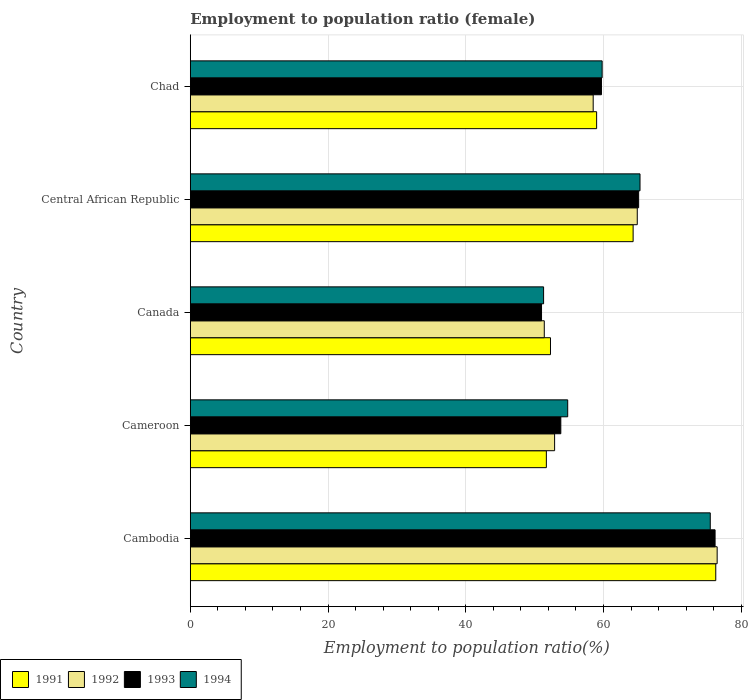Are the number of bars per tick equal to the number of legend labels?
Provide a short and direct response. Yes. How many bars are there on the 5th tick from the top?
Ensure brevity in your answer.  4. What is the label of the 5th group of bars from the top?
Keep it short and to the point. Cambodia. In how many cases, is the number of bars for a given country not equal to the number of legend labels?
Your response must be concise. 0. Across all countries, what is the maximum employment to population ratio in 1992?
Offer a terse response. 76.5. In which country was the employment to population ratio in 1993 maximum?
Your answer should be compact. Cambodia. What is the total employment to population ratio in 1991 in the graph?
Provide a short and direct response. 303.6. What is the difference between the employment to population ratio in 1993 in Canada and that in Chad?
Give a very brief answer. -8.7. What is the difference between the employment to population ratio in 1991 in Chad and the employment to population ratio in 1993 in Canada?
Offer a terse response. 8. What is the average employment to population ratio in 1993 per country?
Make the answer very short. 61.16. What is the difference between the employment to population ratio in 1992 and employment to population ratio in 1993 in Cambodia?
Ensure brevity in your answer.  0.3. In how many countries, is the employment to population ratio in 1991 greater than 32 %?
Your response must be concise. 5. What is the ratio of the employment to population ratio in 1994 in Central African Republic to that in Chad?
Offer a very short reply. 1.09. What is the difference between the highest and the second highest employment to population ratio in 1993?
Keep it short and to the point. 11.1. What is the difference between the highest and the lowest employment to population ratio in 1991?
Your response must be concise. 24.6. Is the sum of the employment to population ratio in 1994 in Cambodia and Central African Republic greater than the maximum employment to population ratio in 1992 across all countries?
Ensure brevity in your answer.  Yes. Is it the case that in every country, the sum of the employment to population ratio in 1992 and employment to population ratio in 1993 is greater than the sum of employment to population ratio in 1991 and employment to population ratio in 1994?
Keep it short and to the point. No. What does the 3rd bar from the top in Chad represents?
Give a very brief answer. 1992. What does the 1st bar from the bottom in Central African Republic represents?
Offer a very short reply. 1991. Are all the bars in the graph horizontal?
Your response must be concise. Yes. How many countries are there in the graph?
Your answer should be compact. 5. What is the difference between two consecutive major ticks on the X-axis?
Your answer should be very brief. 20. Does the graph contain any zero values?
Your answer should be compact. No. How are the legend labels stacked?
Offer a very short reply. Horizontal. What is the title of the graph?
Make the answer very short. Employment to population ratio (female). What is the label or title of the Y-axis?
Keep it short and to the point. Country. What is the Employment to population ratio(%) of 1991 in Cambodia?
Your answer should be very brief. 76.3. What is the Employment to population ratio(%) of 1992 in Cambodia?
Make the answer very short. 76.5. What is the Employment to population ratio(%) in 1993 in Cambodia?
Give a very brief answer. 76.2. What is the Employment to population ratio(%) of 1994 in Cambodia?
Provide a succinct answer. 75.5. What is the Employment to population ratio(%) in 1991 in Cameroon?
Your answer should be very brief. 51.7. What is the Employment to population ratio(%) of 1992 in Cameroon?
Keep it short and to the point. 52.9. What is the Employment to population ratio(%) of 1993 in Cameroon?
Provide a succinct answer. 53.8. What is the Employment to population ratio(%) of 1994 in Cameroon?
Your answer should be compact. 54.8. What is the Employment to population ratio(%) in 1991 in Canada?
Provide a succinct answer. 52.3. What is the Employment to population ratio(%) in 1992 in Canada?
Give a very brief answer. 51.4. What is the Employment to population ratio(%) of 1994 in Canada?
Your answer should be very brief. 51.3. What is the Employment to population ratio(%) in 1991 in Central African Republic?
Keep it short and to the point. 64.3. What is the Employment to population ratio(%) in 1992 in Central African Republic?
Keep it short and to the point. 64.9. What is the Employment to population ratio(%) of 1993 in Central African Republic?
Your answer should be compact. 65.1. What is the Employment to population ratio(%) of 1994 in Central African Republic?
Make the answer very short. 65.3. What is the Employment to population ratio(%) of 1991 in Chad?
Offer a terse response. 59. What is the Employment to population ratio(%) in 1992 in Chad?
Ensure brevity in your answer.  58.5. What is the Employment to population ratio(%) in 1993 in Chad?
Your answer should be very brief. 59.7. What is the Employment to population ratio(%) of 1994 in Chad?
Provide a short and direct response. 59.8. Across all countries, what is the maximum Employment to population ratio(%) of 1991?
Your answer should be compact. 76.3. Across all countries, what is the maximum Employment to population ratio(%) in 1992?
Keep it short and to the point. 76.5. Across all countries, what is the maximum Employment to population ratio(%) of 1993?
Make the answer very short. 76.2. Across all countries, what is the maximum Employment to population ratio(%) of 1994?
Keep it short and to the point. 75.5. Across all countries, what is the minimum Employment to population ratio(%) in 1991?
Keep it short and to the point. 51.7. Across all countries, what is the minimum Employment to population ratio(%) in 1992?
Give a very brief answer. 51.4. Across all countries, what is the minimum Employment to population ratio(%) in 1994?
Provide a short and direct response. 51.3. What is the total Employment to population ratio(%) in 1991 in the graph?
Your answer should be compact. 303.6. What is the total Employment to population ratio(%) of 1992 in the graph?
Give a very brief answer. 304.2. What is the total Employment to population ratio(%) in 1993 in the graph?
Offer a very short reply. 305.8. What is the total Employment to population ratio(%) of 1994 in the graph?
Your response must be concise. 306.7. What is the difference between the Employment to population ratio(%) in 1991 in Cambodia and that in Cameroon?
Make the answer very short. 24.6. What is the difference between the Employment to population ratio(%) of 1992 in Cambodia and that in Cameroon?
Offer a very short reply. 23.6. What is the difference between the Employment to population ratio(%) of 1993 in Cambodia and that in Cameroon?
Your response must be concise. 22.4. What is the difference between the Employment to population ratio(%) of 1994 in Cambodia and that in Cameroon?
Your answer should be compact. 20.7. What is the difference between the Employment to population ratio(%) of 1992 in Cambodia and that in Canada?
Your response must be concise. 25.1. What is the difference between the Employment to population ratio(%) in 1993 in Cambodia and that in Canada?
Make the answer very short. 25.2. What is the difference between the Employment to population ratio(%) of 1994 in Cambodia and that in Canada?
Your answer should be very brief. 24.2. What is the difference between the Employment to population ratio(%) of 1994 in Cambodia and that in Central African Republic?
Ensure brevity in your answer.  10.2. What is the difference between the Employment to population ratio(%) of 1992 in Cambodia and that in Chad?
Your answer should be compact. 18. What is the difference between the Employment to population ratio(%) in 1991 in Cameroon and that in Canada?
Your answer should be compact. -0.6. What is the difference between the Employment to population ratio(%) of 1991 in Cameroon and that in Central African Republic?
Keep it short and to the point. -12.6. What is the difference between the Employment to population ratio(%) in 1992 in Cameroon and that in Central African Republic?
Keep it short and to the point. -12. What is the difference between the Employment to population ratio(%) of 1994 in Cameroon and that in Central African Republic?
Ensure brevity in your answer.  -10.5. What is the difference between the Employment to population ratio(%) of 1991 in Cameroon and that in Chad?
Your answer should be compact. -7.3. What is the difference between the Employment to population ratio(%) in 1994 in Cameroon and that in Chad?
Give a very brief answer. -5. What is the difference between the Employment to population ratio(%) in 1992 in Canada and that in Central African Republic?
Give a very brief answer. -13.5. What is the difference between the Employment to population ratio(%) in 1993 in Canada and that in Central African Republic?
Offer a terse response. -14.1. What is the difference between the Employment to population ratio(%) of 1993 in Canada and that in Chad?
Make the answer very short. -8.7. What is the difference between the Employment to population ratio(%) in 1991 in Central African Republic and that in Chad?
Give a very brief answer. 5.3. What is the difference between the Employment to population ratio(%) of 1994 in Central African Republic and that in Chad?
Your response must be concise. 5.5. What is the difference between the Employment to population ratio(%) of 1991 in Cambodia and the Employment to population ratio(%) of 1992 in Cameroon?
Offer a very short reply. 23.4. What is the difference between the Employment to population ratio(%) in 1991 in Cambodia and the Employment to population ratio(%) in 1993 in Cameroon?
Offer a terse response. 22.5. What is the difference between the Employment to population ratio(%) of 1991 in Cambodia and the Employment to population ratio(%) of 1994 in Cameroon?
Provide a succinct answer. 21.5. What is the difference between the Employment to population ratio(%) of 1992 in Cambodia and the Employment to population ratio(%) of 1993 in Cameroon?
Your response must be concise. 22.7. What is the difference between the Employment to population ratio(%) in 1992 in Cambodia and the Employment to population ratio(%) in 1994 in Cameroon?
Make the answer very short. 21.7. What is the difference between the Employment to population ratio(%) in 1993 in Cambodia and the Employment to population ratio(%) in 1994 in Cameroon?
Ensure brevity in your answer.  21.4. What is the difference between the Employment to population ratio(%) of 1991 in Cambodia and the Employment to population ratio(%) of 1992 in Canada?
Make the answer very short. 24.9. What is the difference between the Employment to population ratio(%) of 1991 in Cambodia and the Employment to population ratio(%) of 1993 in Canada?
Ensure brevity in your answer.  25.3. What is the difference between the Employment to population ratio(%) of 1992 in Cambodia and the Employment to population ratio(%) of 1994 in Canada?
Your response must be concise. 25.2. What is the difference between the Employment to population ratio(%) of 1993 in Cambodia and the Employment to population ratio(%) of 1994 in Canada?
Ensure brevity in your answer.  24.9. What is the difference between the Employment to population ratio(%) in 1991 in Cambodia and the Employment to population ratio(%) in 1993 in Central African Republic?
Keep it short and to the point. 11.2. What is the difference between the Employment to population ratio(%) in 1991 in Cambodia and the Employment to population ratio(%) in 1994 in Central African Republic?
Offer a terse response. 11. What is the difference between the Employment to population ratio(%) of 1992 in Cambodia and the Employment to population ratio(%) of 1993 in Central African Republic?
Provide a short and direct response. 11.4. What is the difference between the Employment to population ratio(%) of 1992 in Cambodia and the Employment to population ratio(%) of 1994 in Central African Republic?
Your answer should be very brief. 11.2. What is the difference between the Employment to population ratio(%) in 1991 in Cameroon and the Employment to population ratio(%) in 1992 in Canada?
Offer a terse response. 0.3. What is the difference between the Employment to population ratio(%) in 1992 in Cameroon and the Employment to population ratio(%) in 1993 in Canada?
Ensure brevity in your answer.  1.9. What is the difference between the Employment to population ratio(%) of 1991 in Cameroon and the Employment to population ratio(%) of 1992 in Central African Republic?
Give a very brief answer. -13.2. What is the difference between the Employment to population ratio(%) in 1991 in Cameroon and the Employment to population ratio(%) in 1993 in Central African Republic?
Provide a short and direct response. -13.4. What is the difference between the Employment to population ratio(%) of 1993 in Cameroon and the Employment to population ratio(%) of 1994 in Central African Republic?
Your answer should be compact. -11.5. What is the difference between the Employment to population ratio(%) of 1991 in Cameroon and the Employment to population ratio(%) of 1994 in Chad?
Provide a succinct answer. -8.1. What is the difference between the Employment to population ratio(%) of 1993 in Cameroon and the Employment to population ratio(%) of 1994 in Chad?
Offer a terse response. -6. What is the difference between the Employment to population ratio(%) in 1991 in Canada and the Employment to population ratio(%) in 1994 in Central African Republic?
Ensure brevity in your answer.  -13. What is the difference between the Employment to population ratio(%) of 1992 in Canada and the Employment to population ratio(%) of 1993 in Central African Republic?
Your answer should be compact. -13.7. What is the difference between the Employment to population ratio(%) in 1993 in Canada and the Employment to population ratio(%) in 1994 in Central African Republic?
Keep it short and to the point. -14.3. What is the difference between the Employment to population ratio(%) in 1991 in Canada and the Employment to population ratio(%) in 1993 in Chad?
Provide a succinct answer. -7.4. What is the difference between the Employment to population ratio(%) in 1992 in Canada and the Employment to population ratio(%) in 1993 in Chad?
Ensure brevity in your answer.  -8.3. What is the difference between the Employment to population ratio(%) in 1992 in Canada and the Employment to population ratio(%) in 1994 in Chad?
Provide a succinct answer. -8.4. What is the difference between the Employment to population ratio(%) in 1991 in Central African Republic and the Employment to population ratio(%) in 1993 in Chad?
Offer a very short reply. 4.6. What is the difference between the Employment to population ratio(%) of 1991 in Central African Republic and the Employment to population ratio(%) of 1994 in Chad?
Provide a short and direct response. 4.5. What is the difference between the Employment to population ratio(%) of 1992 in Central African Republic and the Employment to population ratio(%) of 1993 in Chad?
Provide a succinct answer. 5.2. What is the difference between the Employment to population ratio(%) in 1992 in Central African Republic and the Employment to population ratio(%) in 1994 in Chad?
Give a very brief answer. 5.1. What is the average Employment to population ratio(%) of 1991 per country?
Ensure brevity in your answer.  60.72. What is the average Employment to population ratio(%) of 1992 per country?
Give a very brief answer. 60.84. What is the average Employment to population ratio(%) in 1993 per country?
Your answer should be compact. 61.16. What is the average Employment to population ratio(%) of 1994 per country?
Make the answer very short. 61.34. What is the difference between the Employment to population ratio(%) of 1991 and Employment to population ratio(%) of 1993 in Cambodia?
Your answer should be compact. 0.1. What is the difference between the Employment to population ratio(%) of 1992 and Employment to population ratio(%) of 1994 in Cambodia?
Keep it short and to the point. 1. What is the difference between the Employment to population ratio(%) in 1991 and Employment to population ratio(%) in 1993 in Cameroon?
Keep it short and to the point. -2.1. What is the difference between the Employment to population ratio(%) of 1991 and Employment to population ratio(%) of 1994 in Cameroon?
Your answer should be very brief. -3.1. What is the difference between the Employment to population ratio(%) in 1992 and Employment to population ratio(%) in 1993 in Cameroon?
Your answer should be compact. -0.9. What is the difference between the Employment to population ratio(%) in 1992 and Employment to population ratio(%) in 1994 in Cameroon?
Provide a short and direct response. -1.9. What is the difference between the Employment to population ratio(%) in 1991 and Employment to population ratio(%) in 1992 in Canada?
Ensure brevity in your answer.  0.9. What is the difference between the Employment to population ratio(%) in 1992 and Employment to population ratio(%) in 1993 in Canada?
Your response must be concise. 0.4. What is the difference between the Employment to population ratio(%) of 1991 and Employment to population ratio(%) of 1993 in Central African Republic?
Your response must be concise. -0.8. What is the difference between the Employment to population ratio(%) of 1991 and Employment to population ratio(%) of 1994 in Central African Republic?
Offer a terse response. -1. What is the difference between the Employment to population ratio(%) in 1992 and Employment to population ratio(%) in 1993 in Central African Republic?
Offer a terse response. -0.2. What is the difference between the Employment to population ratio(%) of 1993 and Employment to population ratio(%) of 1994 in Central African Republic?
Give a very brief answer. -0.2. What is the difference between the Employment to population ratio(%) in 1992 and Employment to population ratio(%) in 1994 in Chad?
Your answer should be very brief. -1.3. What is the difference between the Employment to population ratio(%) of 1993 and Employment to population ratio(%) of 1994 in Chad?
Provide a short and direct response. -0.1. What is the ratio of the Employment to population ratio(%) of 1991 in Cambodia to that in Cameroon?
Ensure brevity in your answer.  1.48. What is the ratio of the Employment to population ratio(%) of 1992 in Cambodia to that in Cameroon?
Offer a very short reply. 1.45. What is the ratio of the Employment to population ratio(%) of 1993 in Cambodia to that in Cameroon?
Provide a short and direct response. 1.42. What is the ratio of the Employment to population ratio(%) in 1994 in Cambodia to that in Cameroon?
Your answer should be compact. 1.38. What is the ratio of the Employment to population ratio(%) in 1991 in Cambodia to that in Canada?
Your answer should be very brief. 1.46. What is the ratio of the Employment to population ratio(%) of 1992 in Cambodia to that in Canada?
Give a very brief answer. 1.49. What is the ratio of the Employment to population ratio(%) in 1993 in Cambodia to that in Canada?
Provide a succinct answer. 1.49. What is the ratio of the Employment to population ratio(%) in 1994 in Cambodia to that in Canada?
Give a very brief answer. 1.47. What is the ratio of the Employment to population ratio(%) in 1991 in Cambodia to that in Central African Republic?
Your answer should be very brief. 1.19. What is the ratio of the Employment to population ratio(%) of 1992 in Cambodia to that in Central African Republic?
Your response must be concise. 1.18. What is the ratio of the Employment to population ratio(%) in 1993 in Cambodia to that in Central African Republic?
Provide a succinct answer. 1.17. What is the ratio of the Employment to population ratio(%) of 1994 in Cambodia to that in Central African Republic?
Your answer should be very brief. 1.16. What is the ratio of the Employment to population ratio(%) of 1991 in Cambodia to that in Chad?
Ensure brevity in your answer.  1.29. What is the ratio of the Employment to population ratio(%) in 1992 in Cambodia to that in Chad?
Offer a very short reply. 1.31. What is the ratio of the Employment to population ratio(%) of 1993 in Cambodia to that in Chad?
Provide a succinct answer. 1.28. What is the ratio of the Employment to population ratio(%) of 1994 in Cambodia to that in Chad?
Offer a terse response. 1.26. What is the ratio of the Employment to population ratio(%) in 1991 in Cameroon to that in Canada?
Keep it short and to the point. 0.99. What is the ratio of the Employment to population ratio(%) in 1992 in Cameroon to that in Canada?
Make the answer very short. 1.03. What is the ratio of the Employment to population ratio(%) of 1993 in Cameroon to that in Canada?
Ensure brevity in your answer.  1.05. What is the ratio of the Employment to population ratio(%) in 1994 in Cameroon to that in Canada?
Your answer should be very brief. 1.07. What is the ratio of the Employment to population ratio(%) of 1991 in Cameroon to that in Central African Republic?
Make the answer very short. 0.8. What is the ratio of the Employment to population ratio(%) in 1992 in Cameroon to that in Central African Republic?
Offer a very short reply. 0.82. What is the ratio of the Employment to population ratio(%) of 1993 in Cameroon to that in Central African Republic?
Your answer should be very brief. 0.83. What is the ratio of the Employment to population ratio(%) in 1994 in Cameroon to that in Central African Republic?
Your answer should be compact. 0.84. What is the ratio of the Employment to population ratio(%) in 1991 in Cameroon to that in Chad?
Provide a short and direct response. 0.88. What is the ratio of the Employment to population ratio(%) in 1992 in Cameroon to that in Chad?
Ensure brevity in your answer.  0.9. What is the ratio of the Employment to population ratio(%) of 1993 in Cameroon to that in Chad?
Provide a short and direct response. 0.9. What is the ratio of the Employment to population ratio(%) in 1994 in Cameroon to that in Chad?
Keep it short and to the point. 0.92. What is the ratio of the Employment to population ratio(%) of 1991 in Canada to that in Central African Republic?
Give a very brief answer. 0.81. What is the ratio of the Employment to population ratio(%) in 1992 in Canada to that in Central African Republic?
Ensure brevity in your answer.  0.79. What is the ratio of the Employment to population ratio(%) in 1993 in Canada to that in Central African Republic?
Your answer should be very brief. 0.78. What is the ratio of the Employment to population ratio(%) in 1994 in Canada to that in Central African Republic?
Provide a short and direct response. 0.79. What is the ratio of the Employment to population ratio(%) of 1991 in Canada to that in Chad?
Make the answer very short. 0.89. What is the ratio of the Employment to population ratio(%) in 1992 in Canada to that in Chad?
Your response must be concise. 0.88. What is the ratio of the Employment to population ratio(%) of 1993 in Canada to that in Chad?
Your answer should be compact. 0.85. What is the ratio of the Employment to population ratio(%) in 1994 in Canada to that in Chad?
Your answer should be very brief. 0.86. What is the ratio of the Employment to population ratio(%) of 1991 in Central African Republic to that in Chad?
Provide a succinct answer. 1.09. What is the ratio of the Employment to population ratio(%) in 1992 in Central African Republic to that in Chad?
Your response must be concise. 1.11. What is the ratio of the Employment to population ratio(%) of 1993 in Central African Republic to that in Chad?
Ensure brevity in your answer.  1.09. What is the ratio of the Employment to population ratio(%) in 1994 in Central African Republic to that in Chad?
Keep it short and to the point. 1.09. What is the difference between the highest and the second highest Employment to population ratio(%) of 1991?
Offer a very short reply. 12. What is the difference between the highest and the second highest Employment to population ratio(%) of 1992?
Give a very brief answer. 11.6. What is the difference between the highest and the second highest Employment to population ratio(%) in 1994?
Provide a short and direct response. 10.2. What is the difference between the highest and the lowest Employment to population ratio(%) in 1991?
Keep it short and to the point. 24.6. What is the difference between the highest and the lowest Employment to population ratio(%) of 1992?
Provide a succinct answer. 25.1. What is the difference between the highest and the lowest Employment to population ratio(%) of 1993?
Provide a succinct answer. 25.2. What is the difference between the highest and the lowest Employment to population ratio(%) in 1994?
Offer a very short reply. 24.2. 